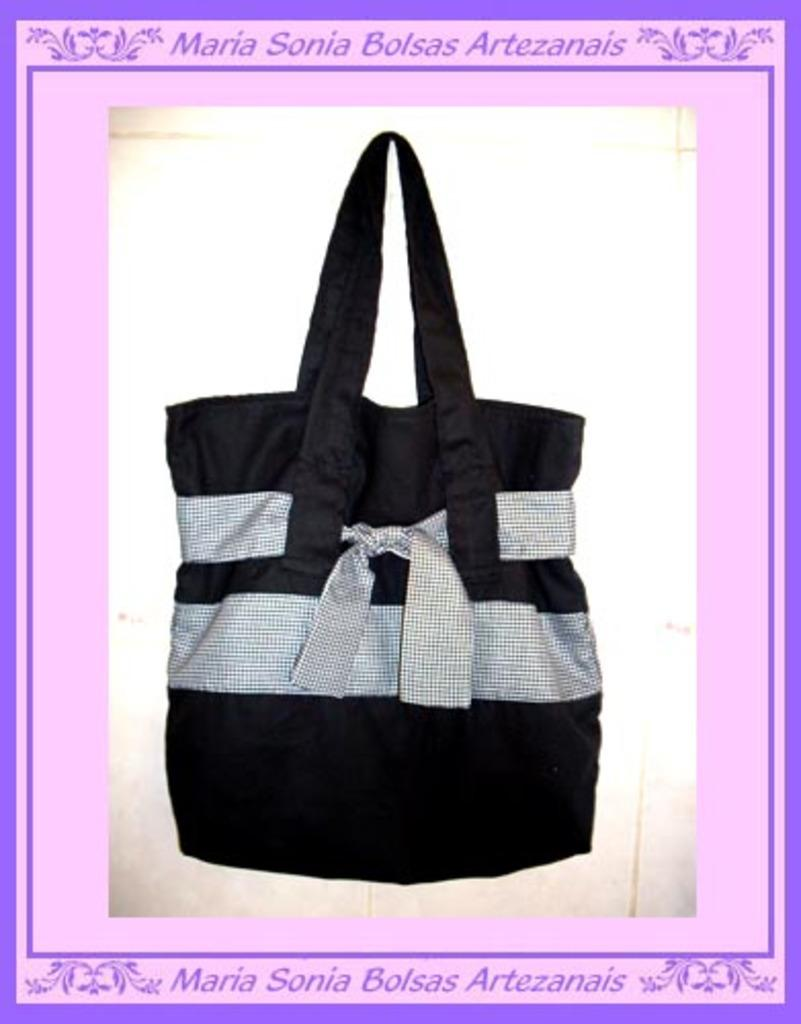What object is present in the image? There is a bag in the image. What design can be seen on the bag? The bag has a blue and pink outline screen. What colors are used for the bag? The bag is in white and black color. Where is the doctor using a hammer on the street in the image? There is no doctor, hammer, or street present in the image; it only features a bag with a blue and pink outline screen on a white and black background. 